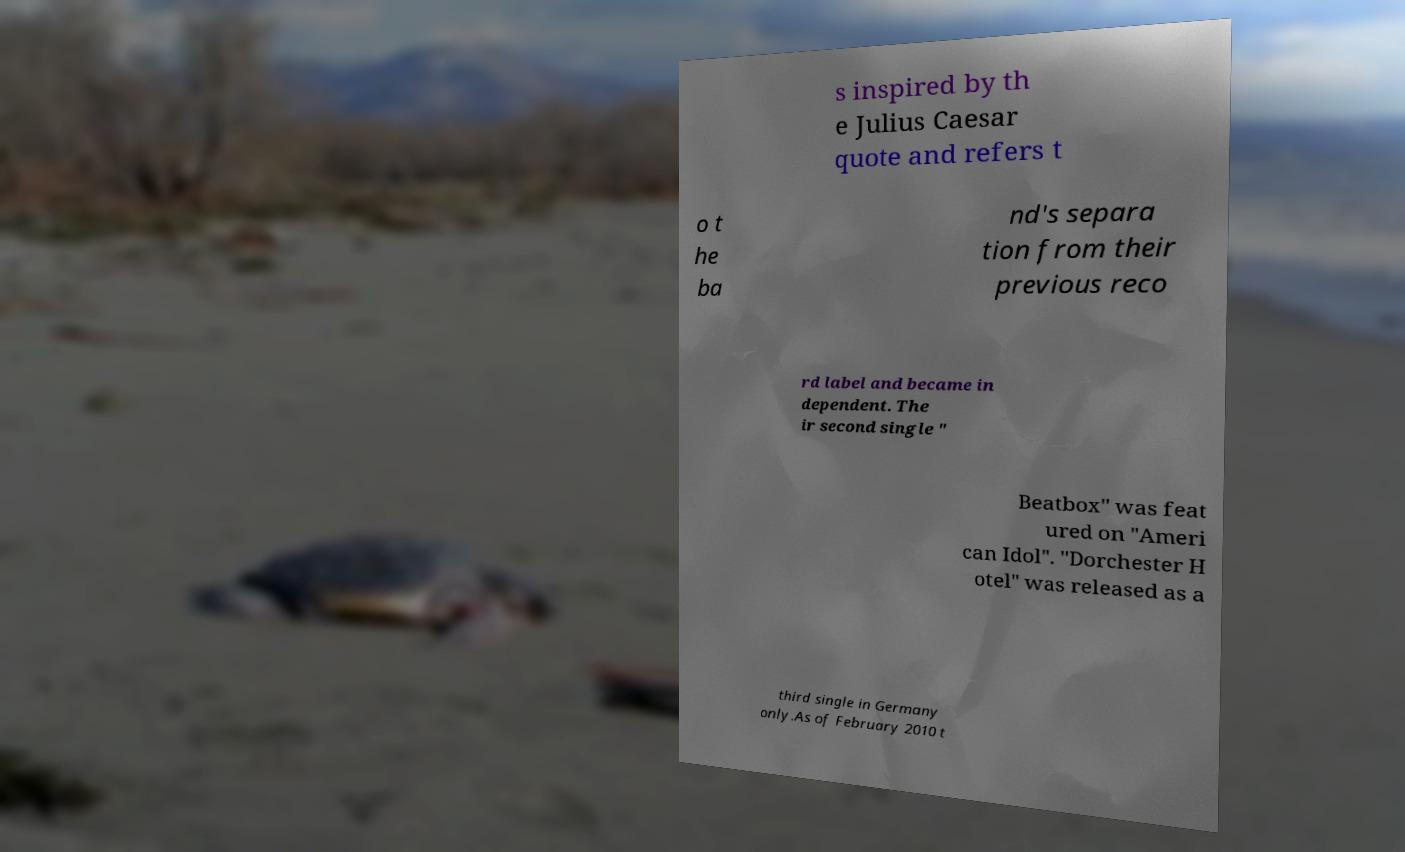I need the written content from this picture converted into text. Can you do that? s inspired by th e Julius Caesar quote and refers t o t he ba nd's separa tion from their previous reco rd label and became in dependent. The ir second single " Beatbox" was feat ured on "Ameri can Idol". "Dorchester H otel" was released as a third single in Germany only.As of February 2010 t 